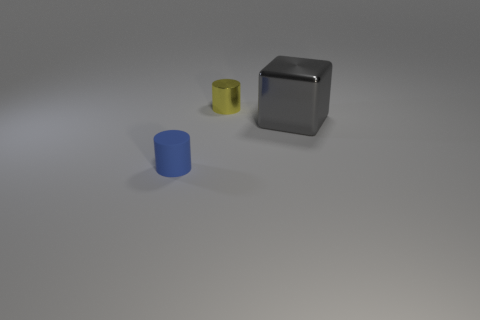Are there any small metallic things behind the cube?
Provide a succinct answer. Yes. What number of other large things have the same material as the big gray object?
Keep it short and to the point. 0. What number of things are tiny blue cylinders or shiny cubes?
Offer a very short reply. 2. Are there any big gray metal blocks?
Your answer should be compact. Yes. There is a tiny cylinder left of the cylinder that is on the right side of the cylinder that is in front of the gray object; what is its material?
Keep it short and to the point. Rubber. Are there fewer yellow objects that are in front of the yellow thing than tiny purple spheres?
Keep it short and to the point. No. What material is the blue cylinder that is the same size as the yellow metal cylinder?
Ensure brevity in your answer.  Rubber. What is the size of the object that is both in front of the tiny yellow shiny object and behind the tiny blue cylinder?
Ensure brevity in your answer.  Large. What number of things are big red metal things or things to the left of the yellow thing?
Your answer should be very brief. 1. The blue rubber object has what shape?
Provide a short and direct response. Cylinder. 